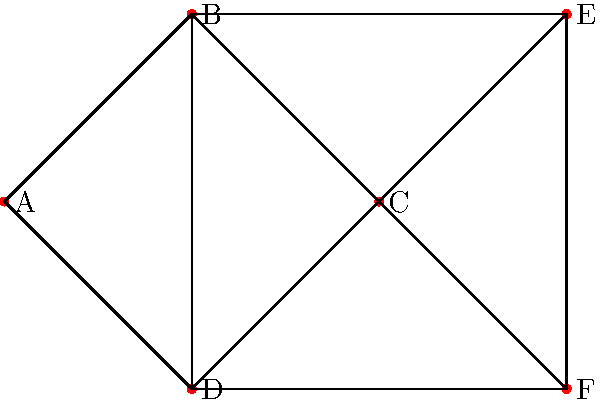Given the network topology diagram above representing a distributed system, what is the minimum number of colors required to color the nodes such that no two adjacent nodes have the same color? This coloring scheme will be used to optimize resource allocation in the network. How does this coloring relate to the chromatic number of the graph? To determine the minimum number of colors required, we need to analyze the graph and apply the concept of graph coloring:

1. First, we identify the most connected node(s). In this case, nodes B and C are connected to 4 other nodes each.

2. We start by coloring node B with color 1.

3. All nodes adjacent to B (A, C, D, E) must have different colors. We can color them as follows:
   A: color 2
   C: color 3
   D: color 3
   E: color 2

4. Now, we need to color node F. It's adjacent to C and D (both color 3), so we can use color 1 or 2. Let's use color 1.

5. We've used 3 colors in total, and no adjacent nodes have the same color.

6. To verify this is the minimum, we can check if it's possible with 2 colors. Since B is connected to 4 other nodes, it's impossible to color all of them with just one other color.

The chromatic number of a graph is defined as the minimum number of colors needed to color the vertices of a graph such that no two adjacent vertices share the same color. In this case, the chromatic number is 3.

This coloring scheme optimizes resource allocation by grouping non-adjacent nodes (which can use the same resources simultaneously) under the same color, maximizing parallel processing and minimizing conflicts in the distributed system.
Answer: 3 colors (chromatic number = 3) 